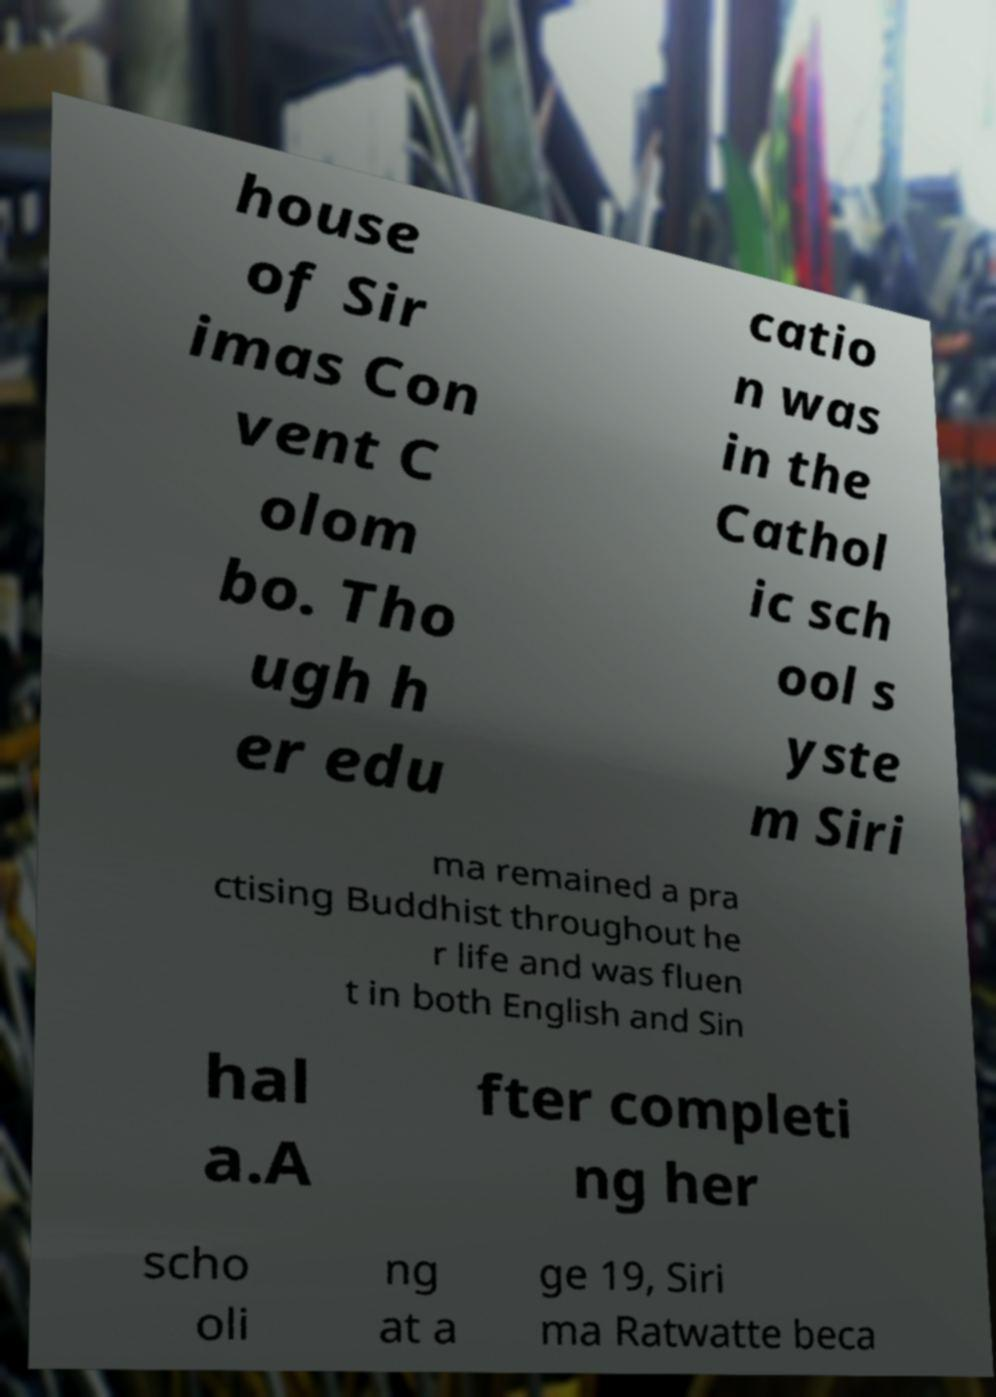I need the written content from this picture converted into text. Can you do that? house of Sir imas Con vent C olom bo. Tho ugh h er edu catio n was in the Cathol ic sch ool s yste m Siri ma remained a pra ctising Buddhist throughout he r life and was fluen t in both English and Sin hal a.A fter completi ng her scho oli ng at a ge 19, Siri ma Ratwatte beca 